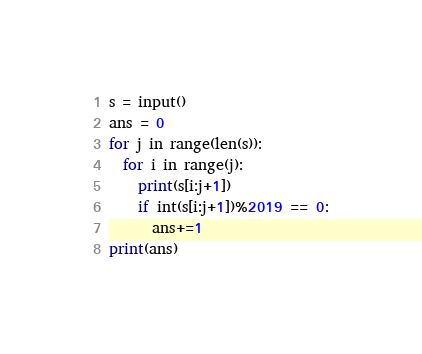Convert code to text. <code><loc_0><loc_0><loc_500><loc_500><_Cython_>s = input()
ans = 0
for j in range(len(s)):
  for i in range(j):
    print(s[i:j+1])
    if int(s[i:j+1])%2019 == 0:
      ans+=1
print(ans)</code> 